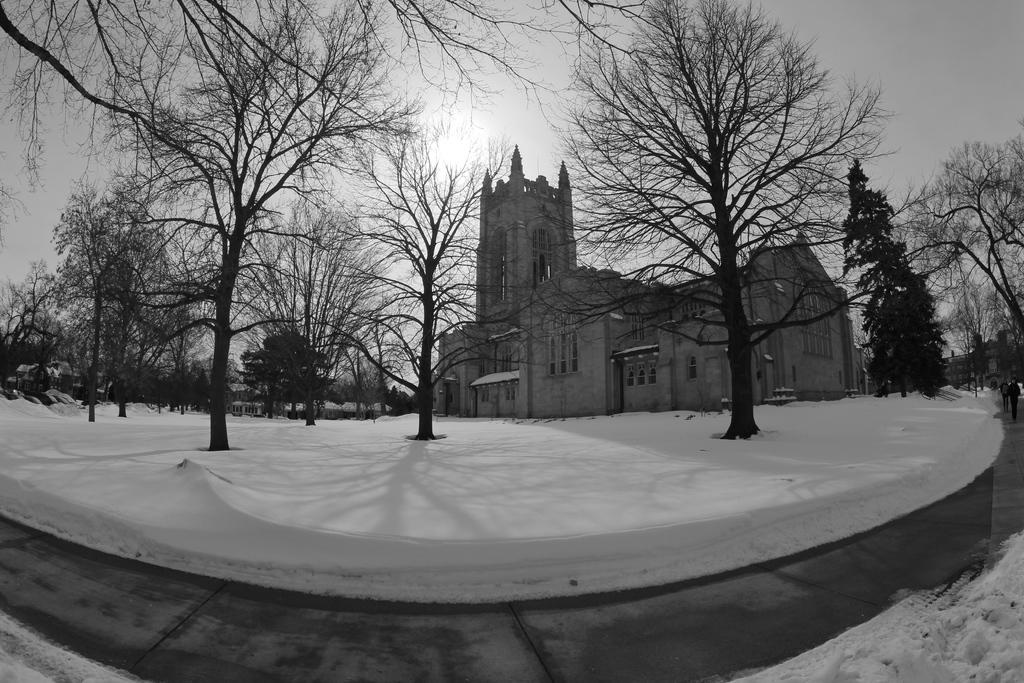What is the color scheme of the image? The image is black and white. What type of structures can be seen in the image? There are buildings in the image. What natural elements are present in the image? There are trees in the image. Are there any living beings in the image? Yes, there are people in the image. What is the ground condition at the bottom of the image? There is snow and a road at the bottom of the image. What type of cover is being used by the trees in the image? There is no mention of any cover being used by the trees in the image; they are simply visible as part of the natural elements. 